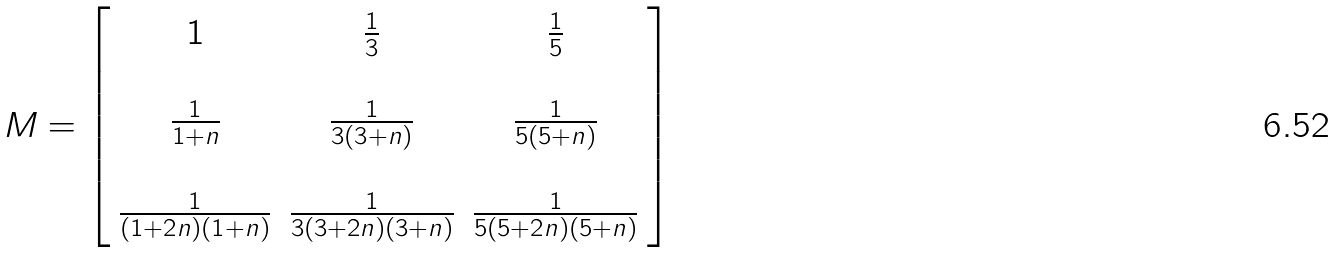<formula> <loc_0><loc_0><loc_500><loc_500>M = \left [ \begin{array} { c c c } 1 & \frac { 1 } { 3 } & \frac { 1 } { 5 } \\ \\ \frac { 1 } { 1 + n } & \frac { 1 } { 3 ( 3 + n ) } & \frac { 1 } { 5 ( 5 + n ) } \\ \\ \frac { 1 } { ( 1 + 2 n ) ( 1 + n ) } & \frac { 1 } { 3 ( 3 + 2 n ) ( 3 + n ) } & \frac { 1 } { 5 ( 5 + 2 n ) ( 5 + n ) } \\ \end{array} \right ]</formula> 